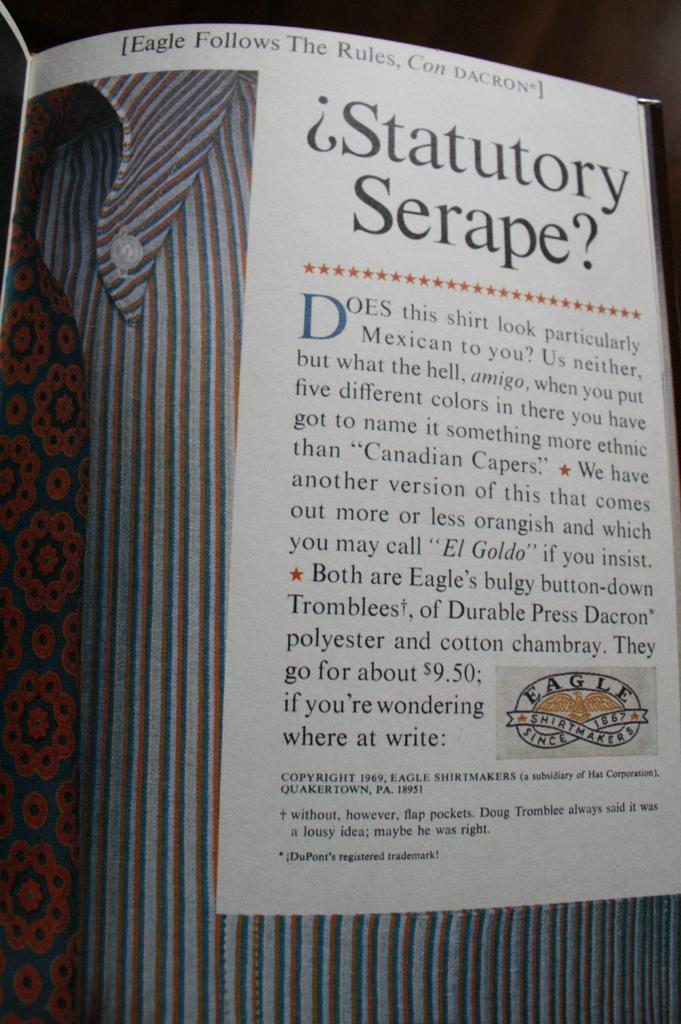Provide a one-sentence caption for the provided image. the word statutory is inside of a magazine. 